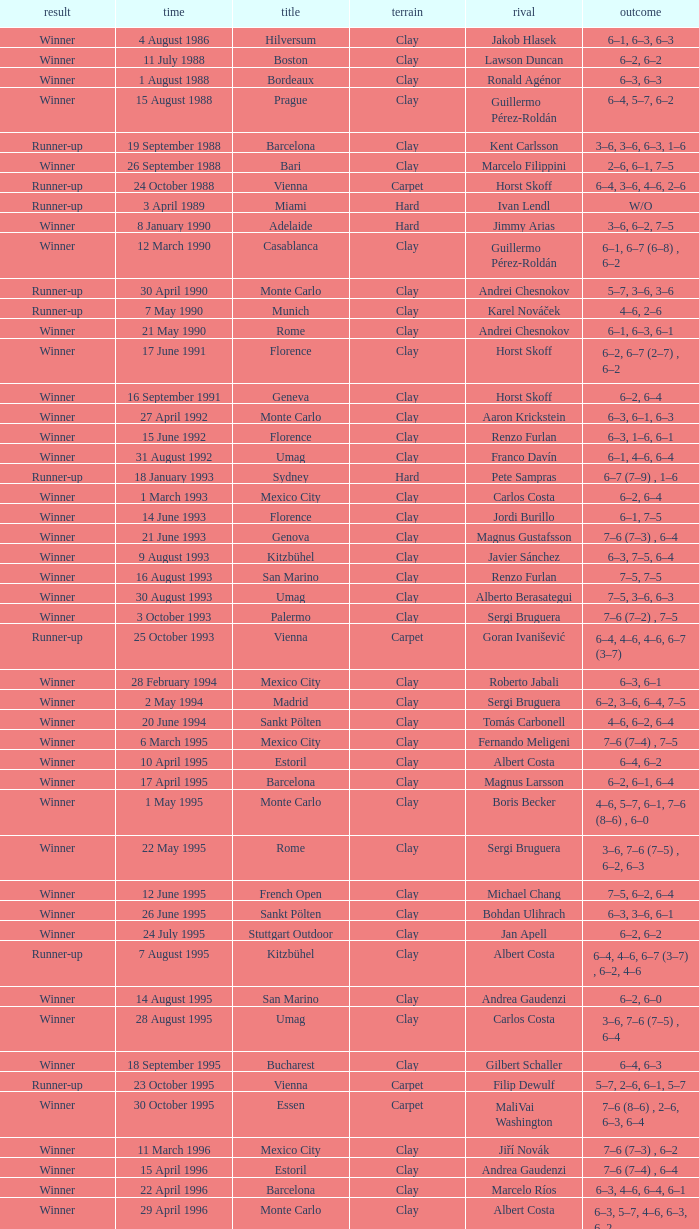What is the score when the championship is rome and the opponent is richard krajicek? 6–2, 6–4, 3–6, 6–3. 